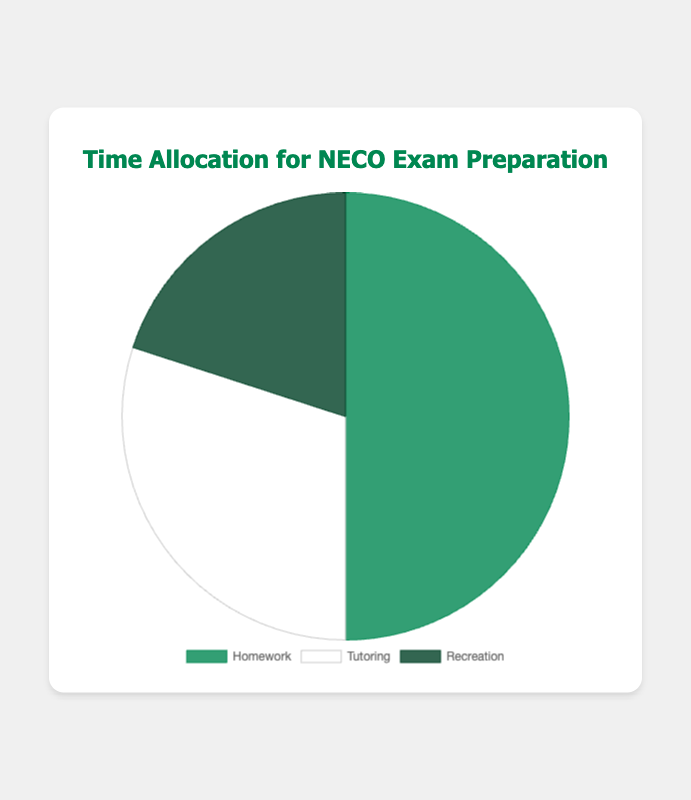What percentage of time is allocated to Homework? In the pie chart, Homework is represented by one of the slices. By looking at the chart, you can see that Homework is allocated 50% of the total time.
Answer: 50% How much more time is allocated to Homework compared to Recreation? Compare the percentage of time allocated to both Homework (50%) and Recreation (20%). Subtract the smaller percentage from the larger one: 50% - 20% = 30%.
Answer: 30% Is the time allocated to Tutoring greater than the time allocated to Recreation? Compare the percentages of time allocated to Tutoring (30%) and Recreation (20%). Since 30% is greater than 20%, the answer is yes.
Answer: Yes What is the total time allocation for Homework and Tutoring combined? Add the percentages of time allocated to Homework (50%) and Tutoring (30%): 50% + 30% = 80%.
Answer: 80% Which activity has the least amount of time allocated to it? Look at the percentages in the pie chart: Homework (50%), Tutoring (30%), and Recreation (20%). Recreation has the smallest percentage.
Answer: Recreation How does the time allocated to Tutoring compare to the combined time allocated to Homework and Recreation? Calculate the combined time for Homework and Recreation: 50% + 20% = 70%. Then, compare it to the time allocated to Tutoring (30%). Since 30% is less than 70%, the combined time is greater.
Answer: The combined time is greater What color represents the time allocated for Tutoring in the pie chart? The visual attributes of the chart show that Tutoring is represented by the white segment.
Answer: White If the total time is to be divided equally among the three activities, how many percentage points would need to be redistributed from Homework to Recreation and Tutoring? Equal division would allocate 33.33% to each activity. Homework has 50%, so 33.33% needs to be subtracted from 50%, resulting in 16.67%. This amount needs to be redistributed to Recreation (20%) and Tutoring (30%) to make them equal, adding approximately 8.33% to each.
Answer: 16.67% Which two activities combined cover more than half of the total time? Compare the combined percentages of each pair: Homework and Tutoring (50% + 30% = 80%), Homework and Recreation (50% + 20% = 70%), and Tutoring and Recreation (30% + 20% = 50%). Both pairs involving Homework exceed 50%.
Answer: Homework and Tutoring, Homework and Recreation 